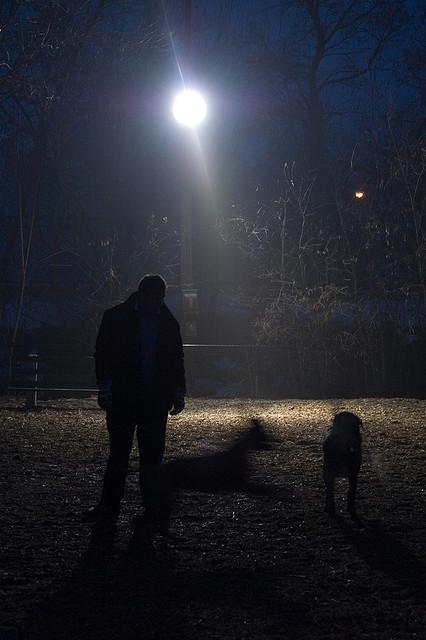How many dogs are there?
Give a very brief answer. 2. 